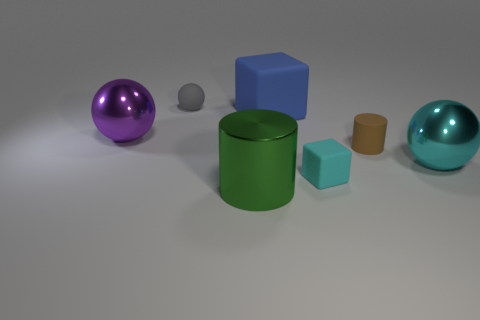The matte cube that is in front of the large sphere in front of the big metallic thing that is left of the green shiny cylinder is what color?
Give a very brief answer. Cyan. Do the brown matte cylinder and the cyan shiny object have the same size?
Your answer should be very brief. No. Is there anything else that has the same shape as the green shiny thing?
Keep it short and to the point. Yes. How many things are either small rubber things that are in front of the large cyan object or small gray objects?
Your answer should be very brief. 2. Does the purple metallic thing have the same shape as the cyan matte object?
Give a very brief answer. No. What number of other objects are the same size as the cyan metallic object?
Provide a succinct answer. 3. The small rubber cube is what color?
Keep it short and to the point. Cyan. What number of large objects are either gray matte cylinders or metal objects?
Offer a very short reply. 3. Does the sphere to the right of the gray object have the same size as the cube that is to the right of the blue thing?
Offer a terse response. No. The other object that is the same shape as the large green metal thing is what size?
Keep it short and to the point. Small. 